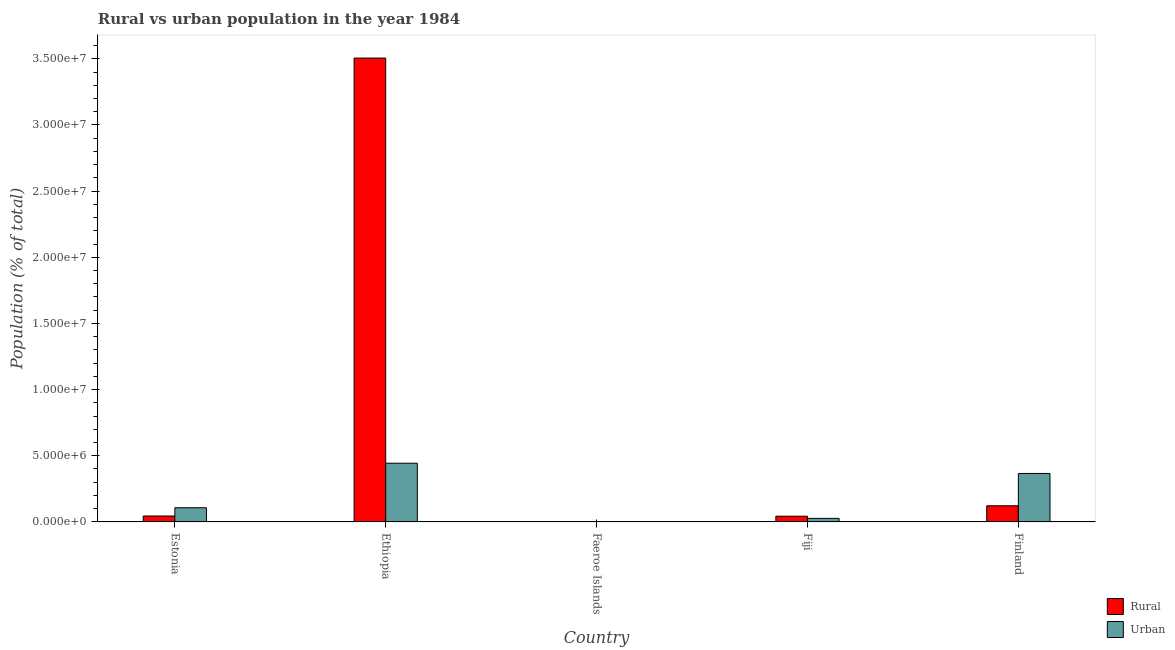Are the number of bars per tick equal to the number of legend labels?
Make the answer very short. Yes. Are the number of bars on each tick of the X-axis equal?
Give a very brief answer. Yes. What is the label of the 3rd group of bars from the left?
Your answer should be very brief. Faeroe Islands. In how many cases, is the number of bars for a given country not equal to the number of legend labels?
Offer a terse response. 0. What is the urban population density in Ethiopia?
Give a very brief answer. 4.44e+06. Across all countries, what is the maximum urban population density?
Offer a very short reply. 4.44e+06. Across all countries, what is the minimum urban population density?
Provide a succinct answer. 1.40e+04. In which country was the urban population density maximum?
Ensure brevity in your answer.  Ethiopia. In which country was the rural population density minimum?
Provide a succinct answer. Faeroe Islands. What is the total rural population density in the graph?
Your answer should be very brief. 3.72e+07. What is the difference between the rural population density in Faeroe Islands and that in Finland?
Ensure brevity in your answer.  -1.19e+06. What is the difference between the urban population density in Fiji and the rural population density in Estonia?
Keep it short and to the point. -1.78e+05. What is the average urban population density per country?
Keep it short and to the point. 1.89e+06. What is the difference between the rural population density and urban population density in Fiji?
Keep it short and to the point. 1.63e+05. What is the ratio of the urban population density in Estonia to that in Finland?
Provide a short and direct response. 0.29. Is the rural population density in Faeroe Islands less than that in Finland?
Your response must be concise. Yes. Is the difference between the urban population density in Ethiopia and Faeroe Islands greater than the difference between the rural population density in Ethiopia and Faeroe Islands?
Provide a short and direct response. No. What is the difference between the highest and the second highest rural population density?
Provide a short and direct response. 3.38e+07. What is the difference between the highest and the lowest rural population density?
Your answer should be compact. 3.50e+07. Is the sum of the rural population density in Fiji and Finland greater than the maximum urban population density across all countries?
Provide a succinct answer. No. What does the 1st bar from the left in Fiji represents?
Give a very brief answer. Rural. What does the 2nd bar from the right in Faeroe Islands represents?
Your answer should be very brief. Rural. What is the difference between two consecutive major ticks on the Y-axis?
Your answer should be very brief. 5.00e+06. Are the values on the major ticks of Y-axis written in scientific E-notation?
Keep it short and to the point. Yes. Does the graph contain any zero values?
Offer a terse response. No. Does the graph contain grids?
Your answer should be compact. No. What is the title of the graph?
Keep it short and to the point. Rural vs urban population in the year 1984. What is the label or title of the Y-axis?
Keep it short and to the point. Population (% of total). What is the Population (% of total) of Rural in Estonia?
Your answer should be compact. 4.47e+05. What is the Population (% of total) in Urban in Estonia?
Give a very brief answer. 1.07e+06. What is the Population (% of total) of Rural in Ethiopia?
Ensure brevity in your answer.  3.51e+07. What is the Population (% of total) in Urban in Ethiopia?
Keep it short and to the point. 4.44e+06. What is the Population (% of total) in Rural in Faeroe Islands?
Keep it short and to the point. 3.13e+04. What is the Population (% of total) in Urban in Faeroe Islands?
Offer a terse response. 1.40e+04. What is the Population (% of total) in Rural in Fiji?
Ensure brevity in your answer.  4.32e+05. What is the Population (% of total) of Urban in Fiji?
Your answer should be very brief. 2.69e+05. What is the Population (% of total) in Rural in Finland?
Provide a short and direct response. 1.22e+06. What is the Population (% of total) of Urban in Finland?
Make the answer very short. 3.66e+06. Across all countries, what is the maximum Population (% of total) of Rural?
Keep it short and to the point. 3.51e+07. Across all countries, what is the maximum Population (% of total) of Urban?
Provide a short and direct response. 4.44e+06. Across all countries, what is the minimum Population (% of total) in Rural?
Your response must be concise. 3.13e+04. Across all countries, what is the minimum Population (% of total) of Urban?
Make the answer very short. 1.40e+04. What is the total Population (% of total) in Rural in the graph?
Provide a short and direct response. 3.72e+07. What is the total Population (% of total) of Urban in the graph?
Your answer should be very brief. 9.45e+06. What is the difference between the Population (% of total) of Rural in Estonia and that in Ethiopia?
Ensure brevity in your answer.  -3.46e+07. What is the difference between the Population (% of total) in Urban in Estonia and that in Ethiopia?
Your answer should be compact. -3.36e+06. What is the difference between the Population (% of total) in Rural in Estonia and that in Faeroe Islands?
Ensure brevity in your answer.  4.16e+05. What is the difference between the Population (% of total) of Urban in Estonia and that in Faeroe Islands?
Ensure brevity in your answer.  1.06e+06. What is the difference between the Population (% of total) of Rural in Estonia and that in Fiji?
Offer a very short reply. 1.55e+04. What is the difference between the Population (% of total) of Urban in Estonia and that in Fiji?
Keep it short and to the point. 8.03e+05. What is the difference between the Population (% of total) in Rural in Estonia and that in Finland?
Your answer should be compact. -7.73e+05. What is the difference between the Population (% of total) in Urban in Estonia and that in Finland?
Give a very brief answer. -2.59e+06. What is the difference between the Population (% of total) in Rural in Ethiopia and that in Faeroe Islands?
Offer a very short reply. 3.50e+07. What is the difference between the Population (% of total) of Urban in Ethiopia and that in Faeroe Islands?
Provide a succinct answer. 4.42e+06. What is the difference between the Population (% of total) in Rural in Ethiopia and that in Fiji?
Provide a succinct answer. 3.46e+07. What is the difference between the Population (% of total) of Urban in Ethiopia and that in Fiji?
Your answer should be very brief. 4.17e+06. What is the difference between the Population (% of total) of Rural in Ethiopia and that in Finland?
Your response must be concise. 3.38e+07. What is the difference between the Population (% of total) in Urban in Ethiopia and that in Finland?
Ensure brevity in your answer.  7.74e+05. What is the difference between the Population (% of total) of Rural in Faeroe Islands and that in Fiji?
Provide a succinct answer. -4.00e+05. What is the difference between the Population (% of total) of Urban in Faeroe Islands and that in Fiji?
Provide a short and direct response. -2.55e+05. What is the difference between the Population (% of total) in Rural in Faeroe Islands and that in Finland?
Your answer should be very brief. -1.19e+06. What is the difference between the Population (% of total) of Urban in Faeroe Islands and that in Finland?
Provide a succinct answer. -3.65e+06. What is the difference between the Population (% of total) of Rural in Fiji and that in Finland?
Provide a succinct answer. -7.88e+05. What is the difference between the Population (% of total) in Urban in Fiji and that in Finland?
Give a very brief answer. -3.39e+06. What is the difference between the Population (% of total) of Rural in Estonia and the Population (% of total) of Urban in Ethiopia?
Provide a short and direct response. -3.99e+06. What is the difference between the Population (% of total) in Rural in Estonia and the Population (% of total) in Urban in Faeroe Islands?
Your answer should be compact. 4.33e+05. What is the difference between the Population (% of total) of Rural in Estonia and the Population (% of total) of Urban in Fiji?
Your answer should be compact. 1.78e+05. What is the difference between the Population (% of total) of Rural in Estonia and the Population (% of total) of Urban in Finland?
Offer a very short reply. -3.21e+06. What is the difference between the Population (% of total) in Rural in Ethiopia and the Population (% of total) in Urban in Faeroe Islands?
Your answer should be very brief. 3.50e+07. What is the difference between the Population (% of total) in Rural in Ethiopia and the Population (% of total) in Urban in Fiji?
Your answer should be very brief. 3.48e+07. What is the difference between the Population (% of total) of Rural in Ethiopia and the Population (% of total) of Urban in Finland?
Your answer should be compact. 3.14e+07. What is the difference between the Population (% of total) in Rural in Faeroe Islands and the Population (% of total) in Urban in Fiji?
Offer a very short reply. -2.37e+05. What is the difference between the Population (% of total) of Rural in Faeroe Islands and the Population (% of total) of Urban in Finland?
Provide a succinct answer. -3.63e+06. What is the difference between the Population (% of total) in Rural in Fiji and the Population (% of total) in Urban in Finland?
Provide a short and direct response. -3.23e+06. What is the average Population (% of total) in Rural per country?
Your response must be concise. 7.44e+06. What is the average Population (% of total) of Urban per country?
Give a very brief answer. 1.89e+06. What is the difference between the Population (% of total) in Rural and Population (% of total) in Urban in Estonia?
Your answer should be compact. -6.24e+05. What is the difference between the Population (% of total) in Rural and Population (% of total) in Urban in Ethiopia?
Your answer should be compact. 3.06e+07. What is the difference between the Population (% of total) of Rural and Population (% of total) of Urban in Faeroe Islands?
Offer a terse response. 1.73e+04. What is the difference between the Population (% of total) in Rural and Population (% of total) in Urban in Fiji?
Your answer should be very brief. 1.63e+05. What is the difference between the Population (% of total) in Rural and Population (% of total) in Urban in Finland?
Provide a succinct answer. -2.44e+06. What is the ratio of the Population (% of total) of Rural in Estonia to that in Ethiopia?
Ensure brevity in your answer.  0.01. What is the ratio of the Population (% of total) in Urban in Estonia to that in Ethiopia?
Make the answer very short. 0.24. What is the ratio of the Population (% of total) of Rural in Estonia to that in Faeroe Islands?
Your answer should be compact. 14.29. What is the ratio of the Population (% of total) in Urban in Estonia to that in Faeroe Islands?
Your answer should be compact. 76.78. What is the ratio of the Population (% of total) in Rural in Estonia to that in Fiji?
Your response must be concise. 1.04. What is the ratio of the Population (% of total) in Urban in Estonia to that in Fiji?
Provide a short and direct response. 3.99. What is the ratio of the Population (% of total) in Rural in Estonia to that in Finland?
Make the answer very short. 0.37. What is the ratio of the Population (% of total) in Urban in Estonia to that in Finland?
Ensure brevity in your answer.  0.29. What is the ratio of the Population (% of total) of Rural in Ethiopia to that in Faeroe Islands?
Your response must be concise. 1120.66. What is the ratio of the Population (% of total) of Urban in Ethiopia to that in Faeroe Islands?
Keep it short and to the point. 317.85. What is the ratio of the Population (% of total) of Rural in Ethiopia to that in Fiji?
Provide a short and direct response. 81.22. What is the ratio of the Population (% of total) of Urban in Ethiopia to that in Fiji?
Offer a terse response. 16.51. What is the ratio of the Population (% of total) of Rural in Ethiopia to that in Finland?
Provide a succinct answer. 28.74. What is the ratio of the Population (% of total) of Urban in Ethiopia to that in Finland?
Your response must be concise. 1.21. What is the ratio of the Population (% of total) of Rural in Faeroe Islands to that in Fiji?
Provide a short and direct response. 0.07. What is the ratio of the Population (% of total) in Urban in Faeroe Islands to that in Fiji?
Your response must be concise. 0.05. What is the ratio of the Population (% of total) of Rural in Faeroe Islands to that in Finland?
Keep it short and to the point. 0.03. What is the ratio of the Population (% of total) in Urban in Faeroe Islands to that in Finland?
Provide a succinct answer. 0. What is the ratio of the Population (% of total) in Rural in Fiji to that in Finland?
Your response must be concise. 0.35. What is the ratio of the Population (% of total) in Urban in Fiji to that in Finland?
Give a very brief answer. 0.07. What is the difference between the highest and the second highest Population (% of total) in Rural?
Offer a terse response. 3.38e+07. What is the difference between the highest and the second highest Population (% of total) in Urban?
Make the answer very short. 7.74e+05. What is the difference between the highest and the lowest Population (% of total) of Rural?
Give a very brief answer. 3.50e+07. What is the difference between the highest and the lowest Population (% of total) in Urban?
Ensure brevity in your answer.  4.42e+06. 